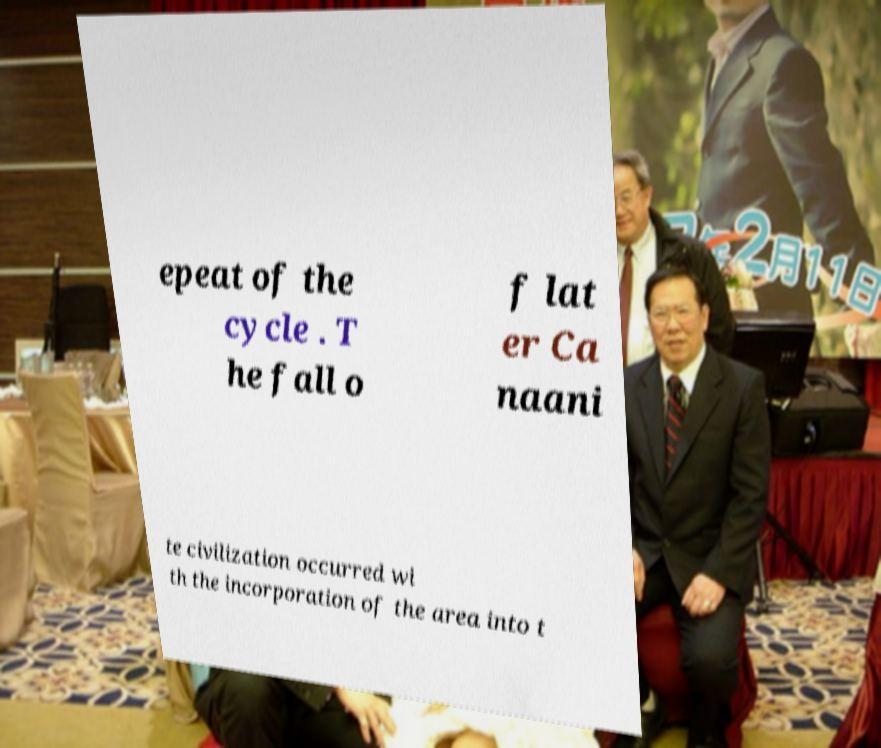Please identify and transcribe the text found in this image. epeat of the cycle . T he fall o f lat er Ca naani te civilization occurred wi th the incorporation of the area into t 